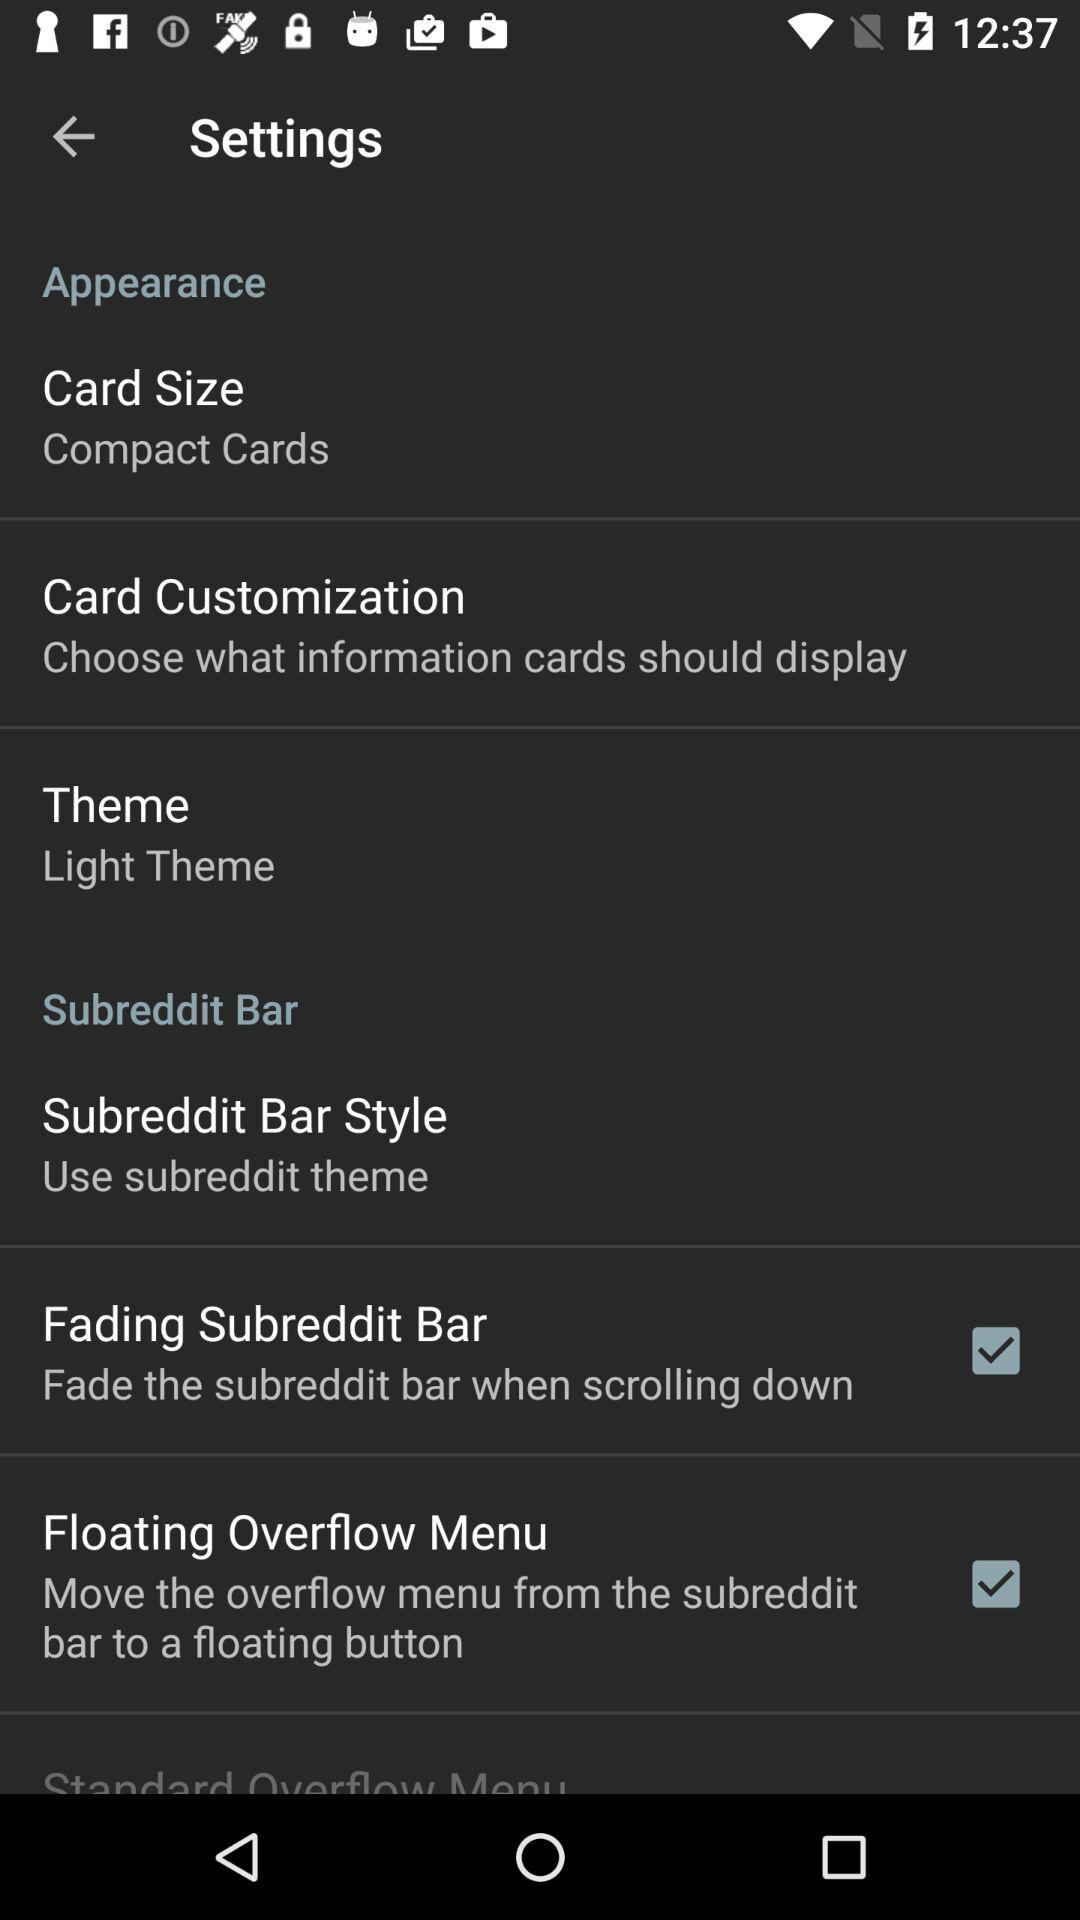How many items in the Appearance section have a checkbox?
Answer the question using a single word or phrase. 2 